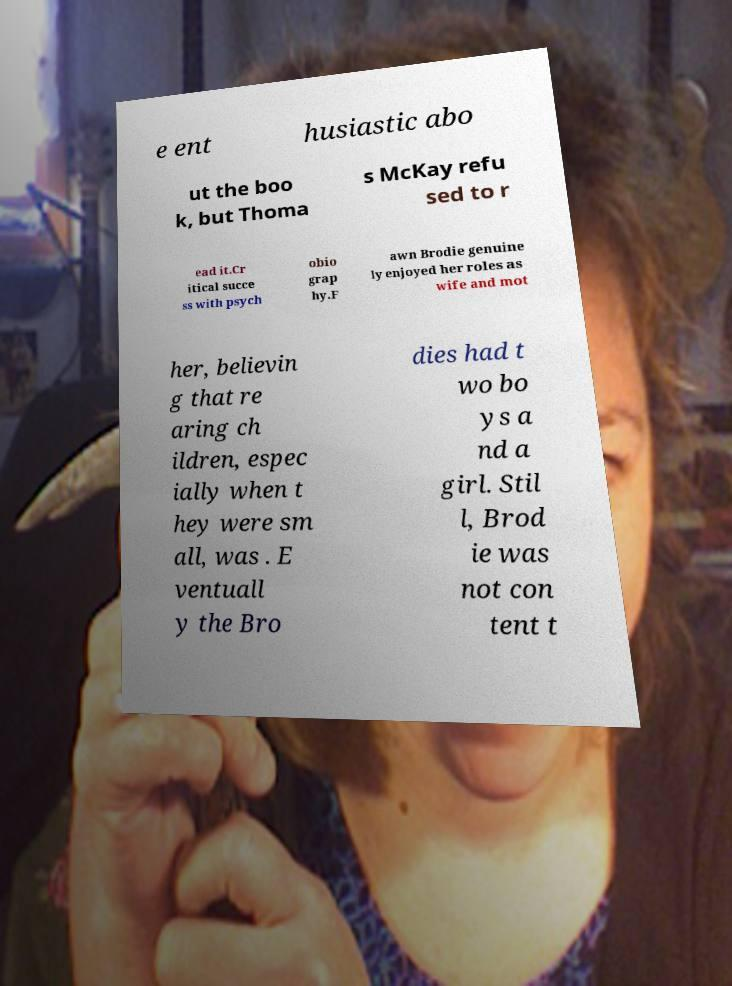Can you read and provide the text displayed in the image?This photo seems to have some interesting text. Can you extract and type it out for me? e ent husiastic abo ut the boo k, but Thoma s McKay refu sed to r ead it.Cr itical succe ss with psych obio grap hy.F awn Brodie genuine ly enjoyed her roles as wife and mot her, believin g that re aring ch ildren, espec ially when t hey were sm all, was . E ventuall y the Bro dies had t wo bo ys a nd a girl. Stil l, Brod ie was not con tent t 